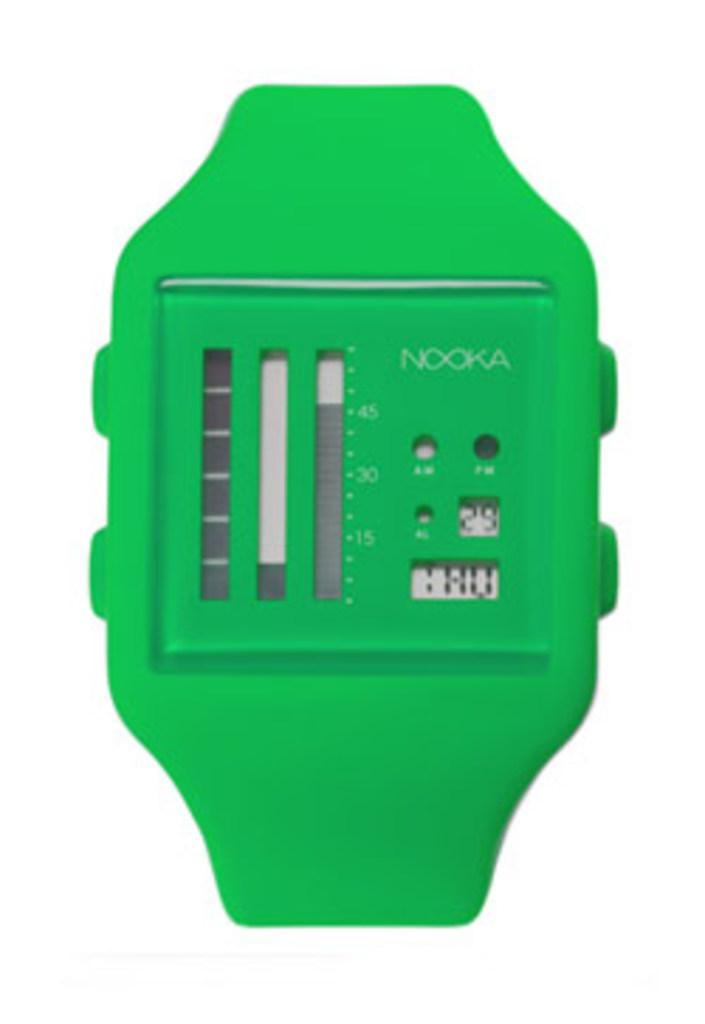<image>
Give a short and clear explanation of the subsequent image. Green wristwatch which says the word NOOKA on top. 